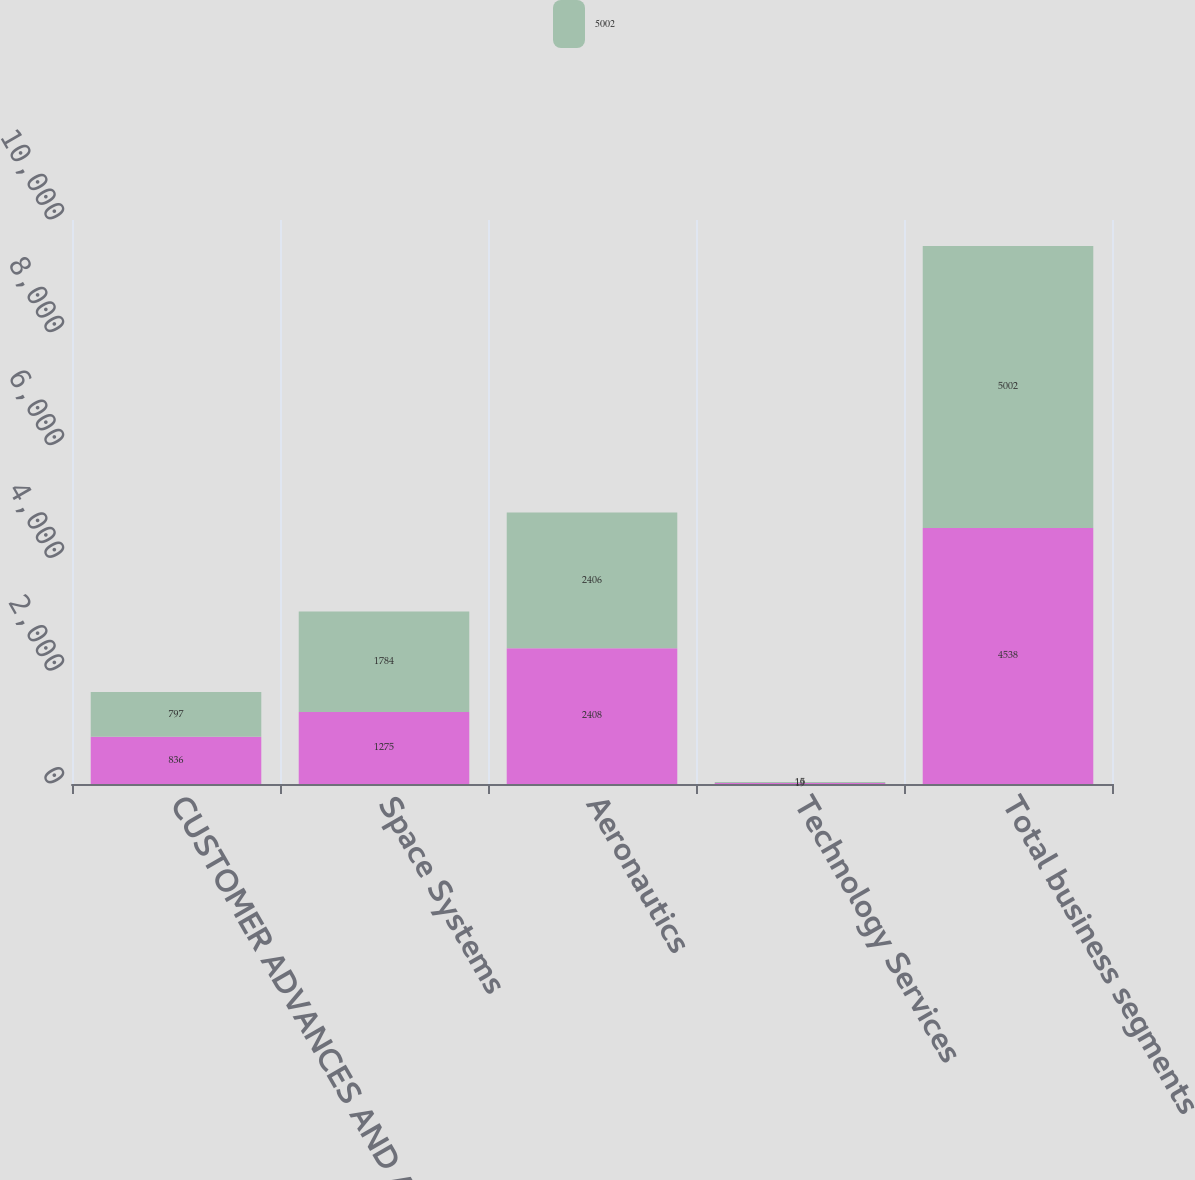Convert chart to OTSL. <chart><loc_0><loc_0><loc_500><loc_500><stacked_bar_chart><ecel><fcel>CUSTOMER ADVANCES AND AMOUNTS<fcel>Space Systems<fcel>Aeronautics<fcel>Technology Services<fcel>Total business segments<nl><fcel>nan<fcel>836<fcel>1275<fcel>2408<fcel>19<fcel>4538<nl><fcel>5002<fcel>797<fcel>1784<fcel>2406<fcel>15<fcel>5002<nl></chart> 